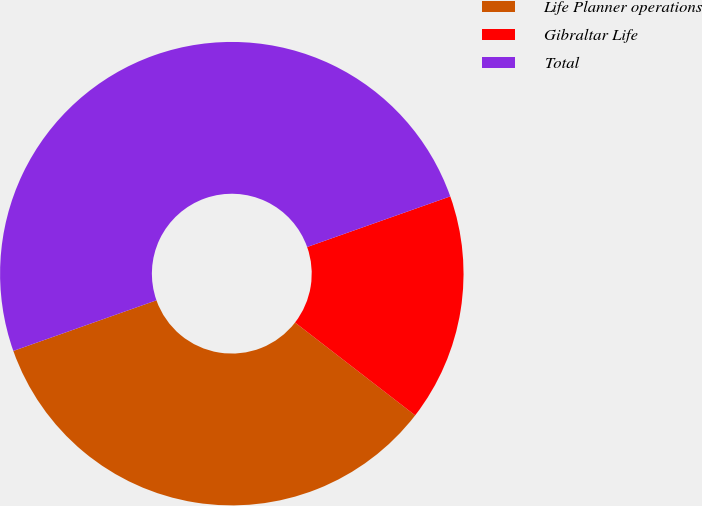Convert chart to OTSL. <chart><loc_0><loc_0><loc_500><loc_500><pie_chart><fcel>Life Planner operations<fcel>Gibraltar Life<fcel>Total<nl><fcel>34.12%<fcel>15.88%<fcel>50.0%<nl></chart> 